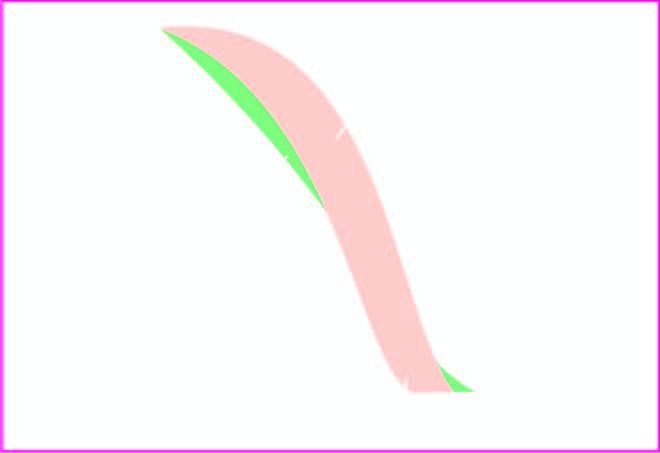what did osmotic fragility testing beta-thalassaemia major show?
Answer the question using a single word or phrase. Decreased fragility 